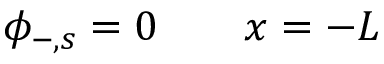Convert formula to latex. <formula><loc_0><loc_0><loc_500><loc_500>\phi _ { - , s } = 0 \quad x = - L</formula> 